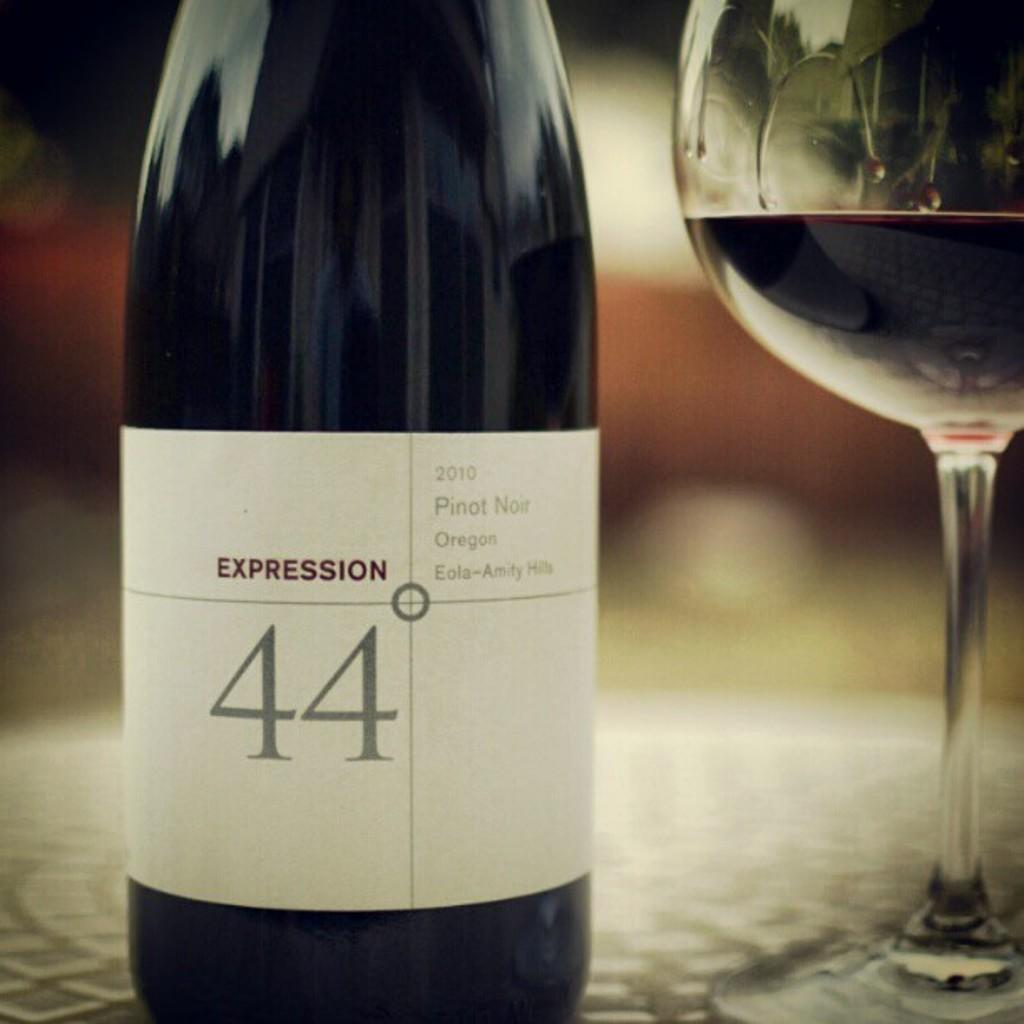<image>
Write a terse but informative summary of the picture. A bottle of red wine with the number 44 written on the label. 